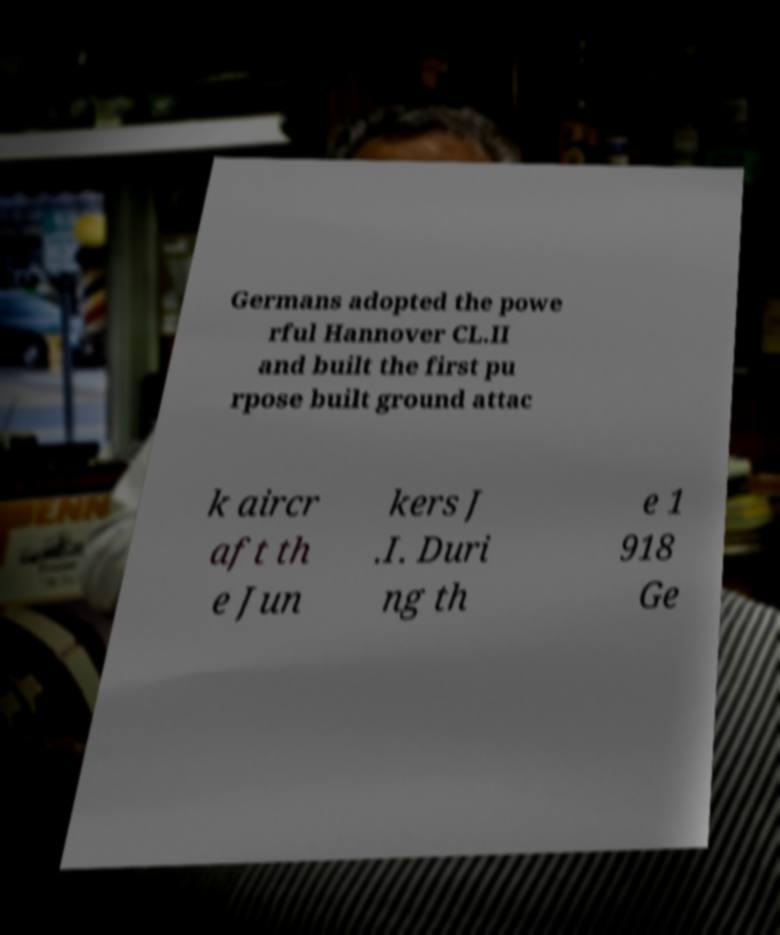Please identify and transcribe the text found in this image. Germans adopted the powe rful Hannover CL.II and built the first pu rpose built ground attac k aircr aft th e Jun kers J .I. Duri ng th e 1 918 Ge 